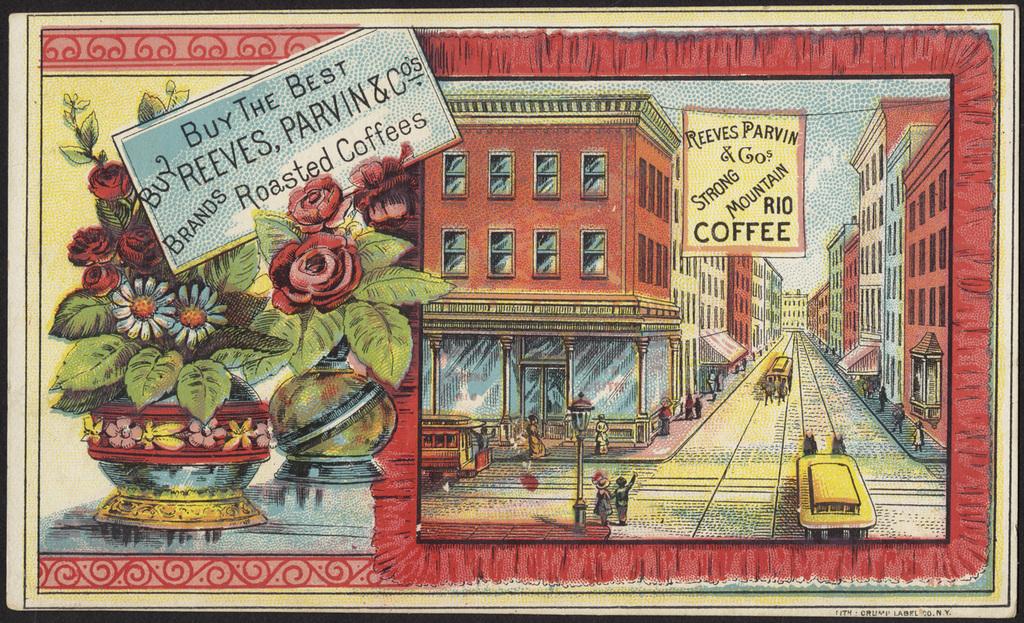What is the name of the store on the illustration?
Keep it short and to the point. Reeves parvin. 